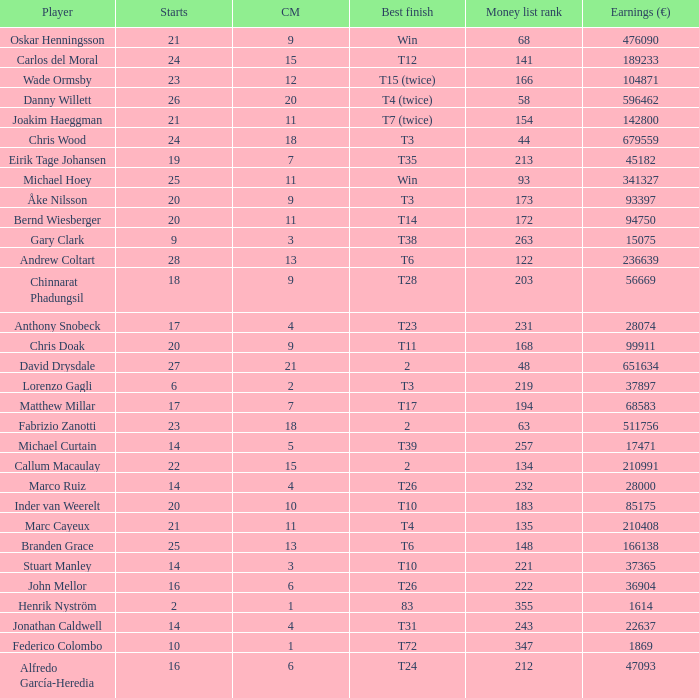How many earnings values are associated with players who had a best finish of T38? 1.0. 